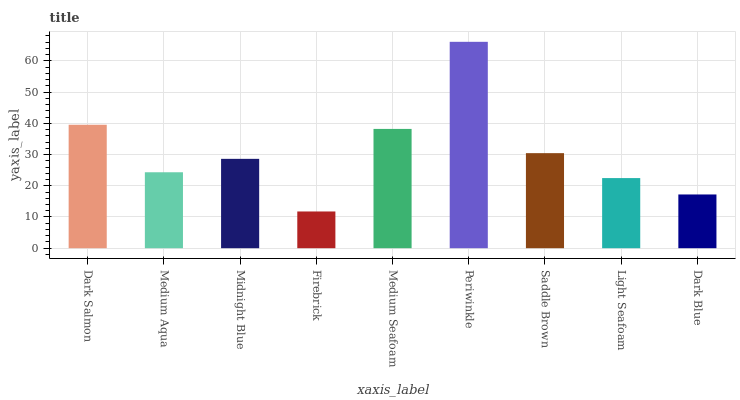Is Firebrick the minimum?
Answer yes or no. Yes. Is Periwinkle the maximum?
Answer yes or no. Yes. Is Medium Aqua the minimum?
Answer yes or no. No. Is Medium Aqua the maximum?
Answer yes or no. No. Is Dark Salmon greater than Medium Aqua?
Answer yes or no. Yes. Is Medium Aqua less than Dark Salmon?
Answer yes or no. Yes. Is Medium Aqua greater than Dark Salmon?
Answer yes or no. No. Is Dark Salmon less than Medium Aqua?
Answer yes or no. No. Is Midnight Blue the high median?
Answer yes or no. Yes. Is Midnight Blue the low median?
Answer yes or no. Yes. Is Periwinkle the high median?
Answer yes or no. No. Is Medium Aqua the low median?
Answer yes or no. No. 